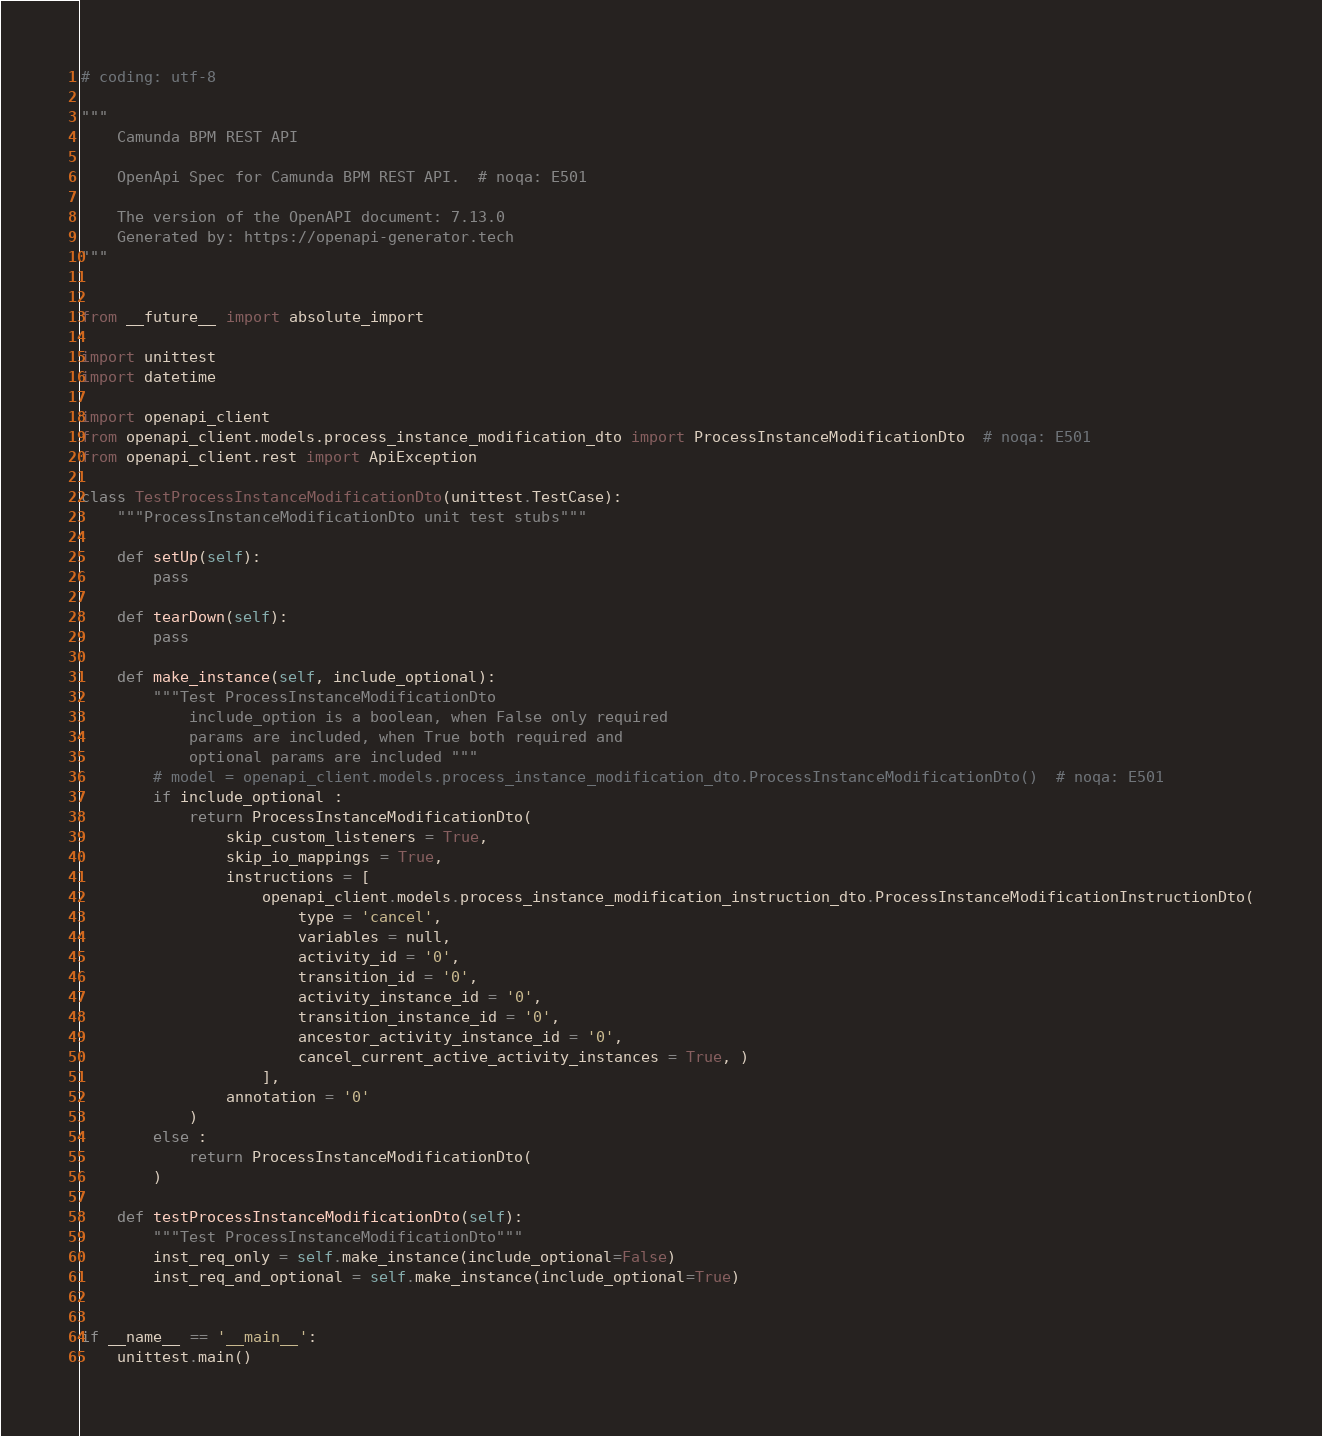Convert code to text. <code><loc_0><loc_0><loc_500><loc_500><_Python_># coding: utf-8

"""
    Camunda BPM REST API

    OpenApi Spec for Camunda BPM REST API.  # noqa: E501

    The version of the OpenAPI document: 7.13.0
    Generated by: https://openapi-generator.tech
"""


from __future__ import absolute_import

import unittest
import datetime

import openapi_client
from openapi_client.models.process_instance_modification_dto import ProcessInstanceModificationDto  # noqa: E501
from openapi_client.rest import ApiException

class TestProcessInstanceModificationDto(unittest.TestCase):
    """ProcessInstanceModificationDto unit test stubs"""

    def setUp(self):
        pass

    def tearDown(self):
        pass

    def make_instance(self, include_optional):
        """Test ProcessInstanceModificationDto
            include_option is a boolean, when False only required
            params are included, when True both required and
            optional params are included """
        # model = openapi_client.models.process_instance_modification_dto.ProcessInstanceModificationDto()  # noqa: E501
        if include_optional :
            return ProcessInstanceModificationDto(
                skip_custom_listeners = True, 
                skip_io_mappings = True, 
                instructions = [
                    openapi_client.models.process_instance_modification_instruction_dto.ProcessInstanceModificationInstructionDto(
                        type = 'cancel', 
                        variables = null, 
                        activity_id = '0', 
                        transition_id = '0', 
                        activity_instance_id = '0', 
                        transition_instance_id = '0', 
                        ancestor_activity_instance_id = '0', 
                        cancel_current_active_activity_instances = True, )
                    ], 
                annotation = '0'
            )
        else :
            return ProcessInstanceModificationDto(
        )

    def testProcessInstanceModificationDto(self):
        """Test ProcessInstanceModificationDto"""
        inst_req_only = self.make_instance(include_optional=False)
        inst_req_and_optional = self.make_instance(include_optional=True)


if __name__ == '__main__':
    unittest.main()
</code> 